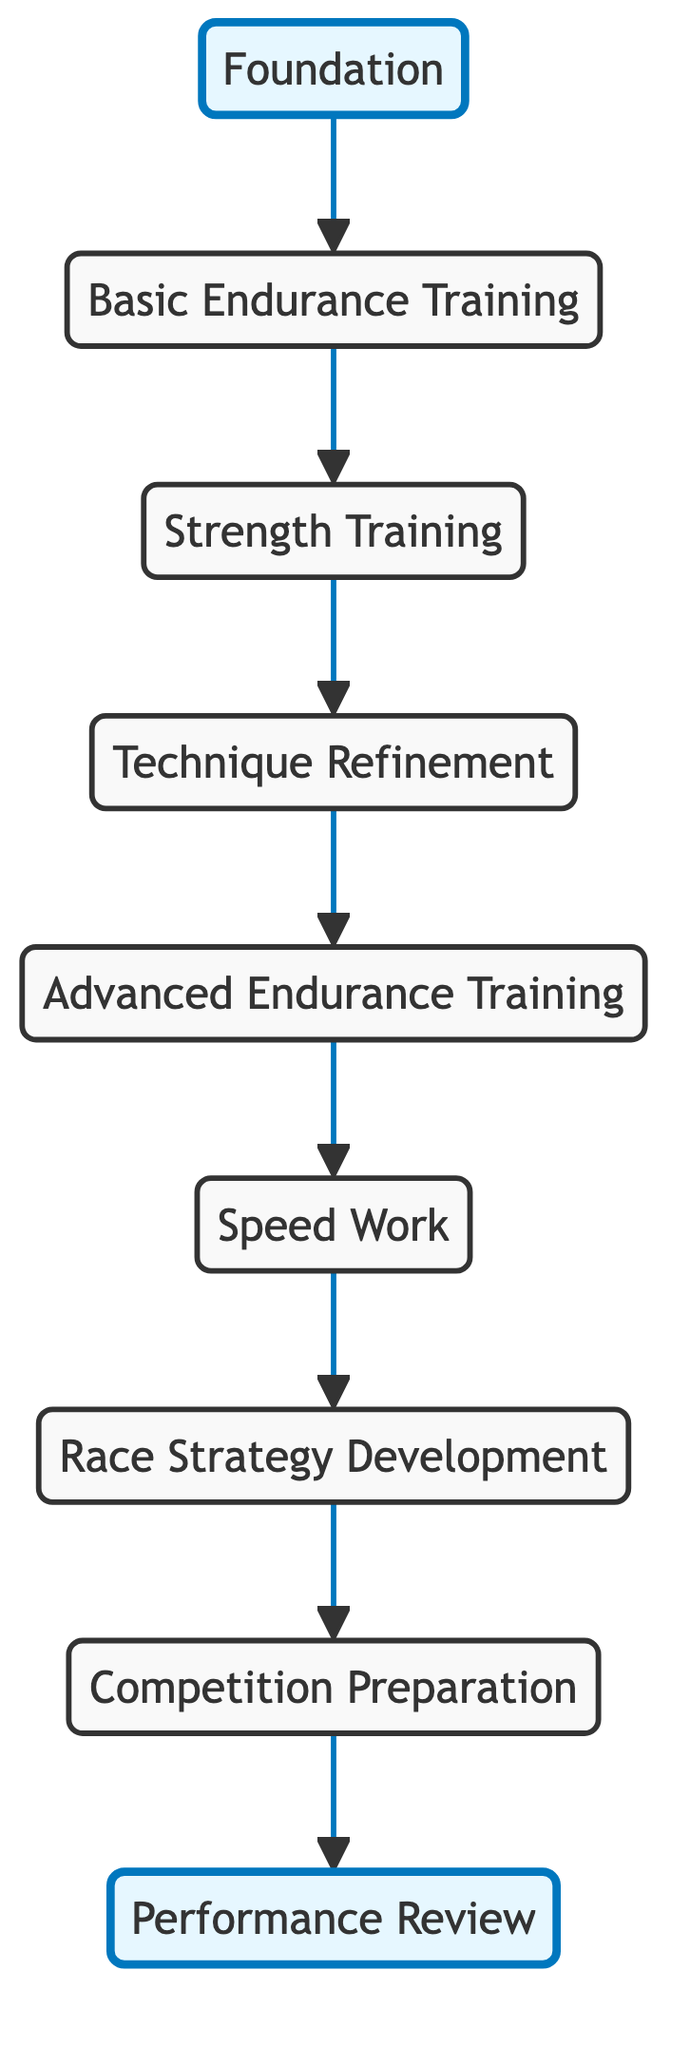What is the highest level in the training progression? The highest level in the progression, as indicated at the top of the flowchart, is "Performance Review." This is confirmed by locating the node at the highest point of the diagram, which is level 9.
Answer: Performance Review How many elements are in the training progression? By counting the nodes displayed in the diagram, there are a total of nine elements, starting from "Foundation" at level 1 up to "Performance Review" at level 9.
Answer: 9 What is the immediate step after "Speed Work"? The node connected directly above "Speed Work" in the diagram is "Race Strategy Development," which comes right after the speed training phase in the progression.
Answer: Race Strategy Development What training follows "Technique Refinement"? Following "Technique Refinement," the next step in the progression, as shown by the upward arrow, is "Advanced Endurance Training." This connection indicates the flow from one level to the next in the chart.
Answer: Advanced Endurance Training Which element focuses on muscle development? The element that specifically emphasizes muscle development is "Strength Training," as indicated by the description highlighting gym exercises and muscle growth at level 3.
Answer: Strength Training What is the relationship between "Basic Endurance Training" and "Strength Training"? "Basic Endurance Training" is the first element that connects to "Strength Training" directly below it in the sequence, indicating that endurance training precedes and supports strength training.
Answer: Basic Endurance Training precedes Strength Training Which two elements are highlighted in the diagram? The highlighted elements in the diagram are "Foundation" and "Performance Review," which are visually distinguished with a specific coloring and marking style to emphasize their importance in the progression.
Answer: Foundation and Performance Review What type of training is performed before "Competition Preparation"? The type of training that occurs immediately prior to "Competition Preparation" is "Race Strategy Development," indicating the tactical training phase before preparing for competitions.
Answer: Race Strategy Development What is the focus of "Advanced Endurance Training"? "Advanced Endurance Training" emphasizes enhancing aerobic capacity through specific training methods like interval training and mixed-intensity paddling sessions, as defined in its description.
Answer: Enhancing aerobic capacity 